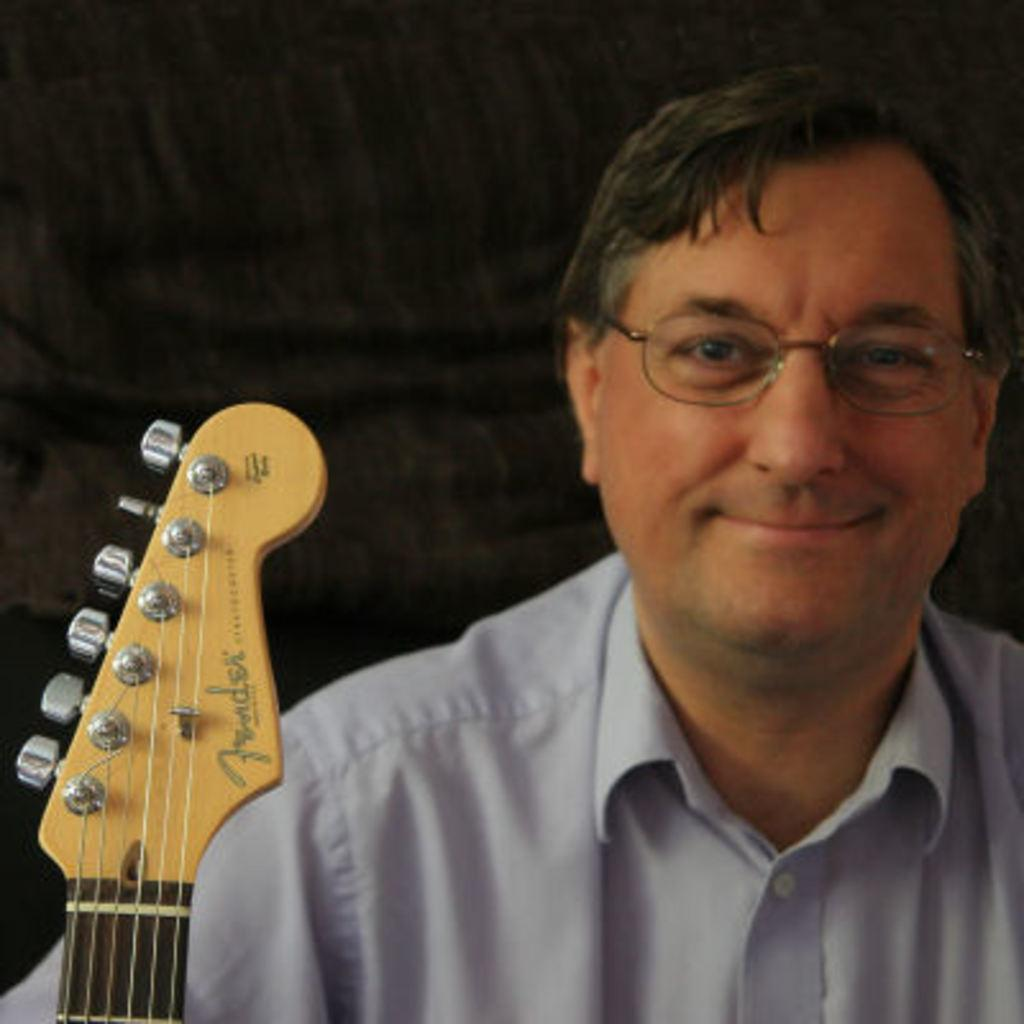Who is present in the image? There is a man in the image. What is the man wearing? The man is wearing a light blue shirt. What is the man's facial expression? The man has a smiling face. What object is in front of the man? There is a guitar in front of the man. How many clovers are on the man's shirt in the image? There are no clovers mentioned or visible on the man's shirt in the image. 